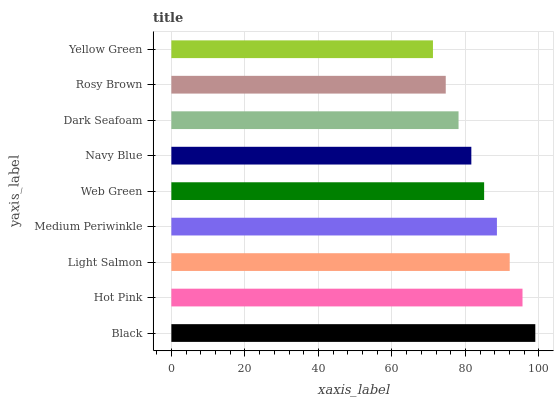Is Yellow Green the minimum?
Answer yes or no. Yes. Is Black the maximum?
Answer yes or no. Yes. Is Hot Pink the minimum?
Answer yes or no. No. Is Hot Pink the maximum?
Answer yes or no. No. Is Black greater than Hot Pink?
Answer yes or no. Yes. Is Hot Pink less than Black?
Answer yes or no. Yes. Is Hot Pink greater than Black?
Answer yes or no. No. Is Black less than Hot Pink?
Answer yes or no. No. Is Web Green the high median?
Answer yes or no. Yes. Is Web Green the low median?
Answer yes or no. Yes. Is Medium Periwinkle the high median?
Answer yes or no. No. Is Hot Pink the low median?
Answer yes or no. No. 